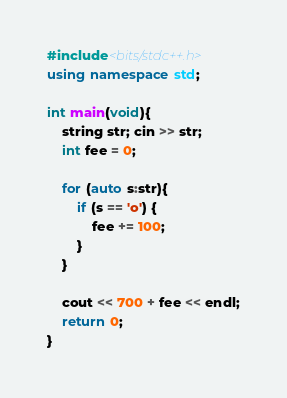Convert code to text. <code><loc_0><loc_0><loc_500><loc_500><_C++_>#include<bits/stdc++.h>
using namespace std;
 
int main(void){
    string str; cin >> str;
    int fee = 0;

    for (auto s:str){
        if (s == 'o') {
            fee += 100;
        }
    }

    cout << 700 + fee << endl;
    return 0;
}</code> 